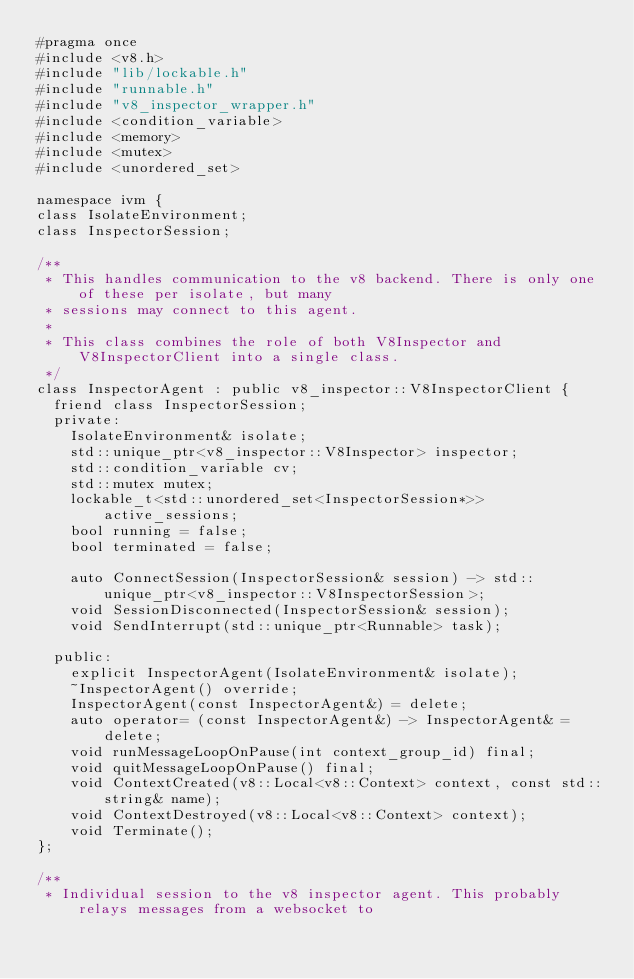<code> <loc_0><loc_0><loc_500><loc_500><_C_>#pragma once
#include <v8.h>
#include "lib/lockable.h"
#include "runnable.h"
#include "v8_inspector_wrapper.h"
#include <condition_variable>
#include <memory>
#include <mutex>
#include <unordered_set>

namespace ivm {
class IsolateEnvironment;
class InspectorSession;

/**
 * This handles communication to the v8 backend. There is only one of these per isolate, but many
 * sessions may connect to this agent.
 *
 * This class combines the role of both V8Inspector and V8InspectorClient into a single class.
 */
class InspectorAgent : public v8_inspector::V8InspectorClient {
	friend class InspectorSession;
	private:
		IsolateEnvironment& isolate;
		std::unique_ptr<v8_inspector::V8Inspector> inspector;
		std::condition_variable cv;
		std::mutex mutex;
		lockable_t<std::unordered_set<InspectorSession*>> active_sessions;
		bool running = false;
		bool terminated = false;

		auto ConnectSession(InspectorSession& session) -> std::unique_ptr<v8_inspector::V8InspectorSession>;
		void SessionDisconnected(InspectorSession& session);
		void SendInterrupt(std::unique_ptr<Runnable> task);

	public:
		explicit InspectorAgent(IsolateEnvironment& isolate);
		~InspectorAgent() override;
		InspectorAgent(const InspectorAgent&) = delete;
		auto operator= (const InspectorAgent&) -> InspectorAgent& = delete;
		void runMessageLoopOnPause(int context_group_id) final;
		void quitMessageLoopOnPause() final;
		void ContextCreated(v8::Local<v8::Context> context, const std::string& name);
		void ContextDestroyed(v8::Local<v8::Context> context);
		void Terminate();
};

/**
 * Individual session to the v8 inspector agent. This probably relays messages from a websocket to</code> 